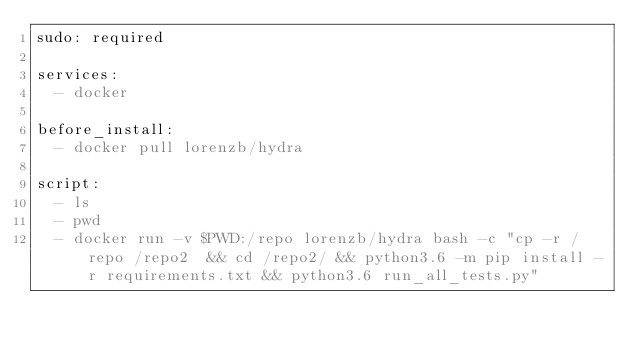<code> <loc_0><loc_0><loc_500><loc_500><_YAML_>sudo: required

services:
  - docker

before_install:
  - docker pull lorenzb/hydra

script:
  - ls
  - pwd
  - docker run -v $PWD:/repo lorenzb/hydra bash -c "cp -r /repo /repo2  && cd /repo2/ && python3.6 -m pip install -r requirements.txt && python3.6 run_all_tests.py"
</code> 